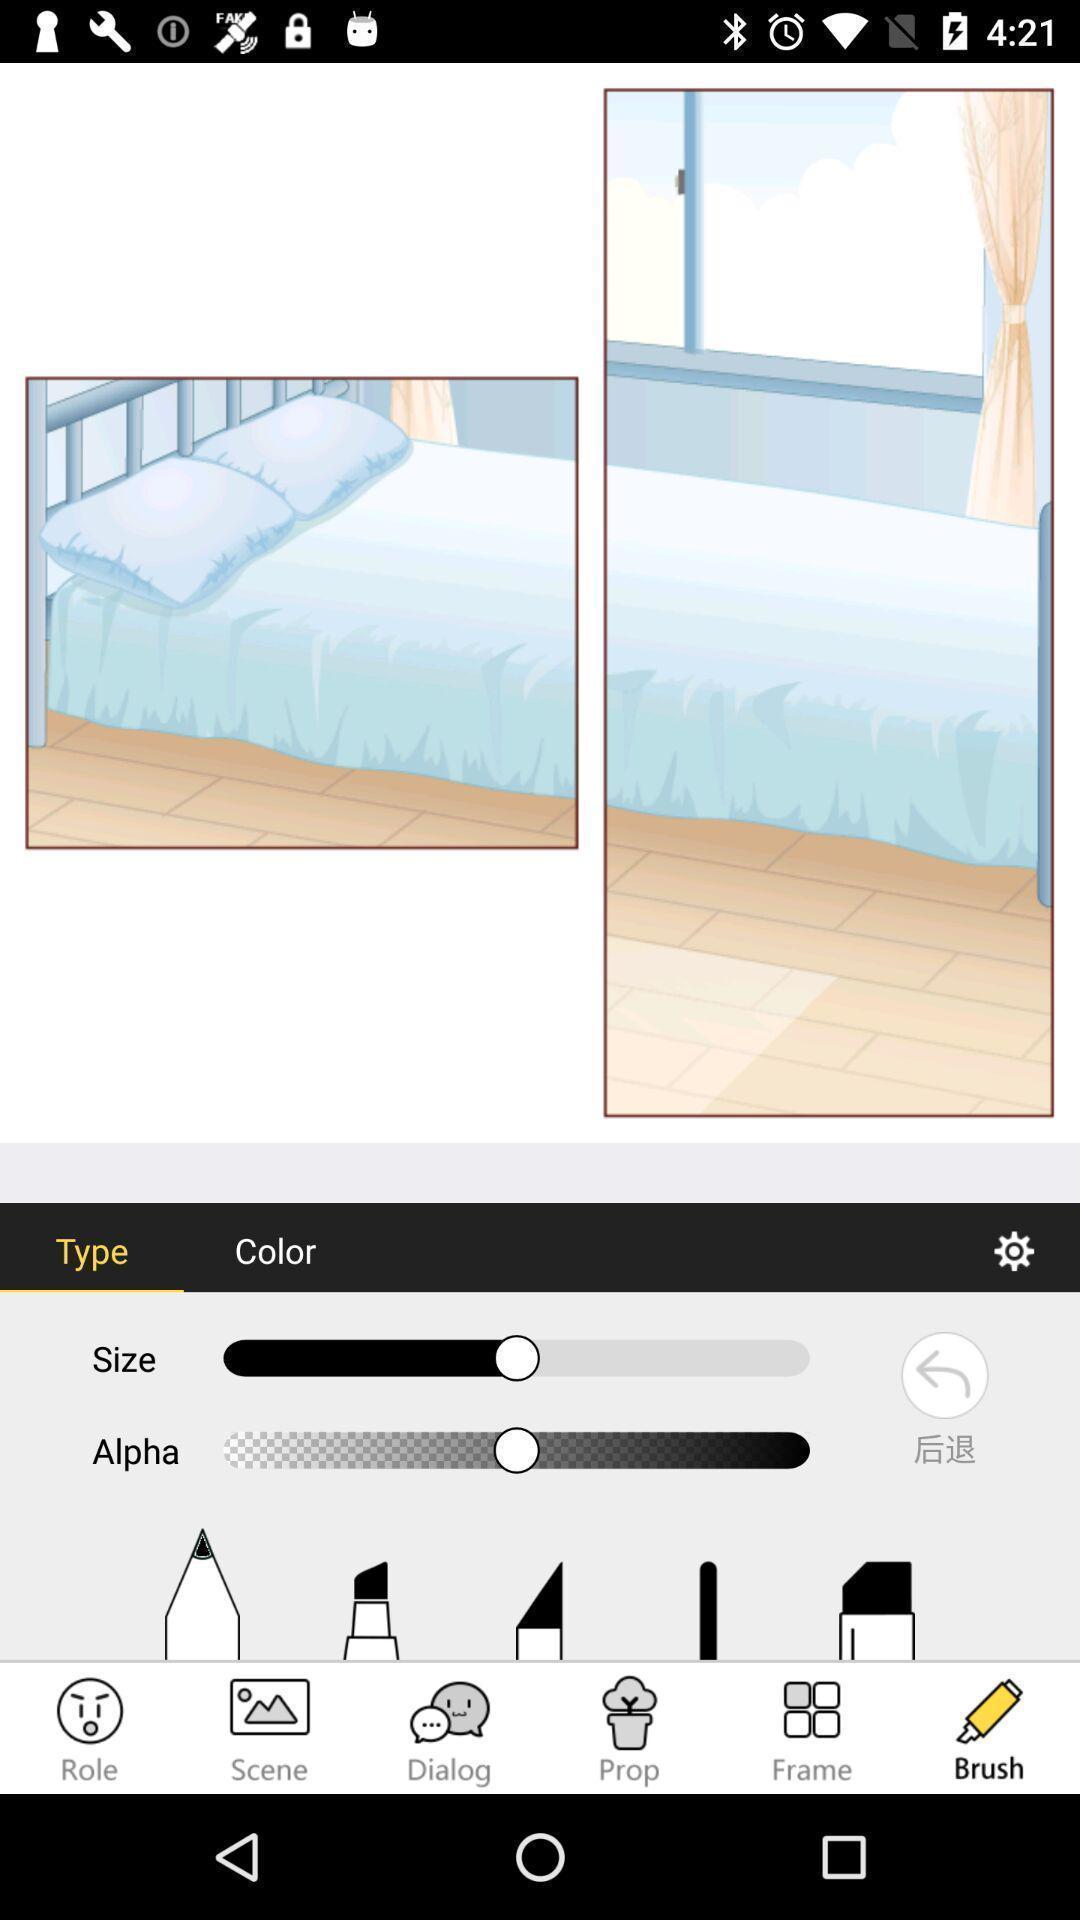Provide a description of this screenshot. Page showing the photo editing app. 